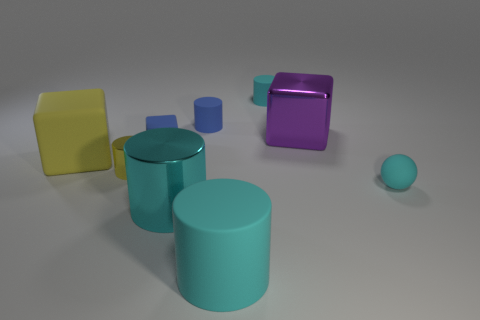Are there any metallic objects in front of the tiny yellow thing?
Your answer should be very brief. Yes. What is the color of the rubber thing that is both in front of the big yellow thing and right of the large cyan rubber object?
Offer a terse response. Cyan. There is a large matte object that is the same color as the large shiny cylinder; what is its shape?
Make the answer very short. Cylinder. There is a cyan thing behind the yellow thing that is left of the small metal cylinder; how big is it?
Give a very brief answer. Small. How many blocks are either large shiny objects or tiny cyan objects?
Offer a very short reply. 1. There is a rubber sphere that is the same size as the blue matte cylinder; what is its color?
Make the answer very short. Cyan. There is a cyan thing that is behind the tiny matte cylinder that is to the left of the small cyan rubber cylinder; what is its shape?
Make the answer very short. Cylinder. There is a rubber cylinder in front of the matte ball; does it have the same size as the purple block?
Your answer should be very brief. Yes. How many other things are made of the same material as the purple object?
Make the answer very short. 2. How many red things are big metal things or cubes?
Ensure brevity in your answer.  0. 